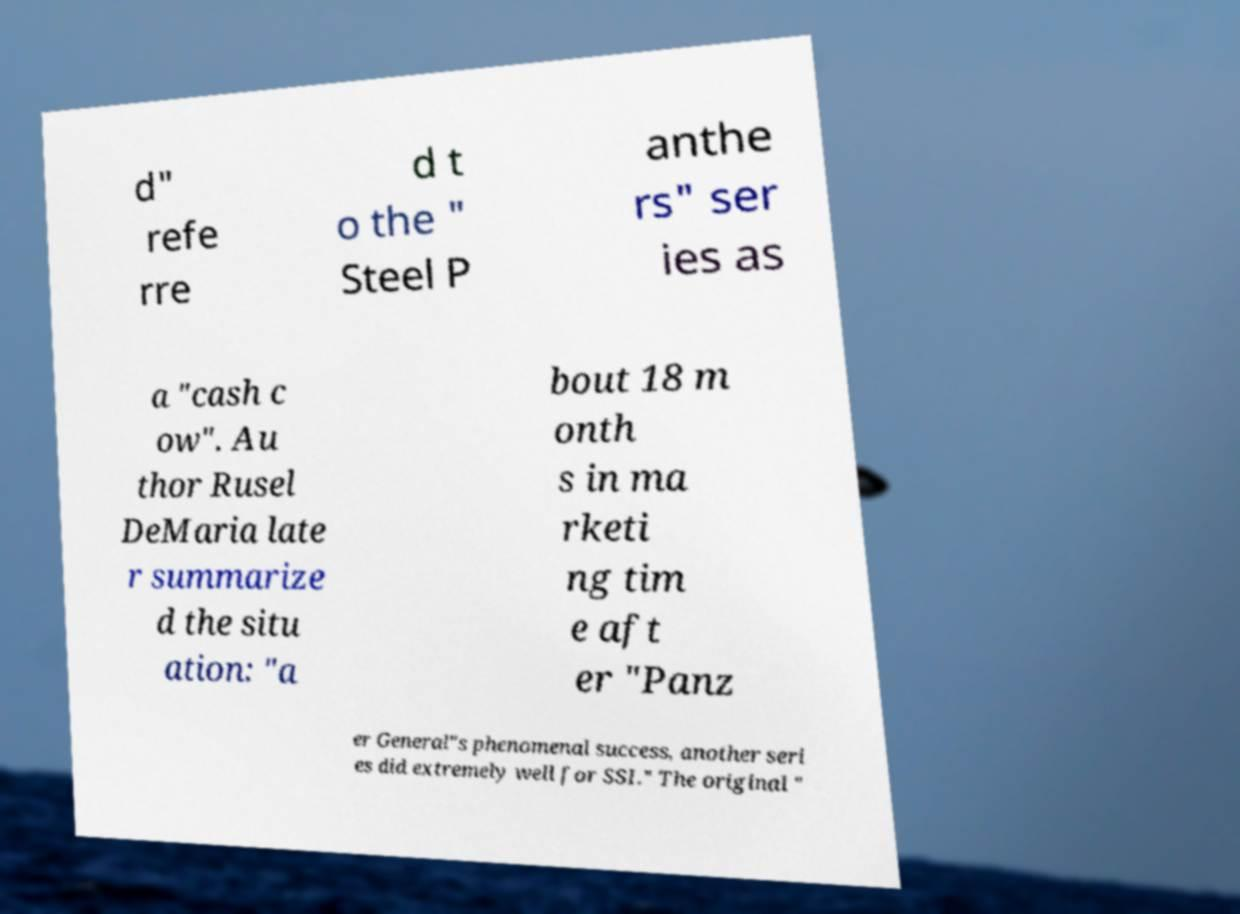Can you read and provide the text displayed in the image?This photo seems to have some interesting text. Can you extract and type it out for me? d" refe rre d t o the " Steel P anthe rs" ser ies as a "cash c ow". Au thor Rusel DeMaria late r summarize d the situ ation: "a bout 18 m onth s in ma rketi ng tim e aft er "Panz er General"s phenomenal success, another seri es did extremely well for SSI." The original " 